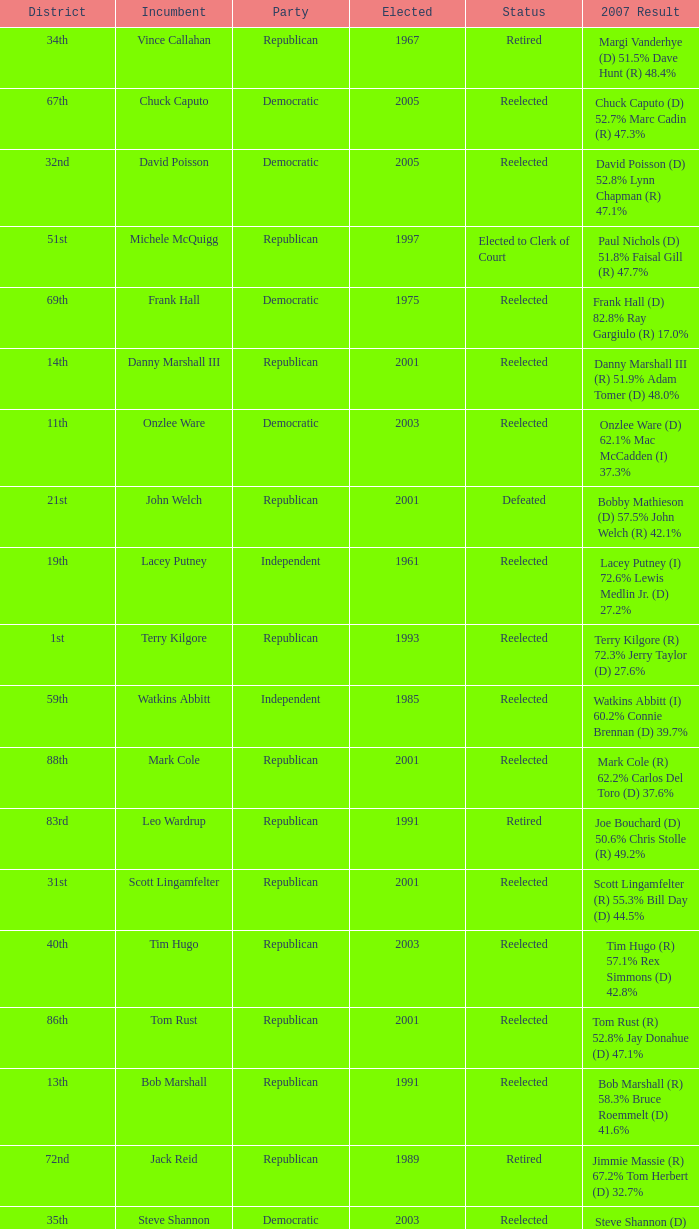How many times was incumbent onzlee ware elected? 1.0. Write the full table. {'header': ['District', 'Incumbent', 'Party', 'Elected', 'Status', '2007 Result'], 'rows': [['34th', 'Vince Callahan', 'Republican', '1967', 'Retired', 'Margi Vanderhye (D) 51.5% Dave Hunt (R) 48.4%'], ['67th', 'Chuck Caputo', 'Democratic', '2005', 'Reelected', 'Chuck Caputo (D) 52.7% Marc Cadin (R) 47.3%'], ['32nd', 'David Poisson', 'Democratic', '2005', 'Reelected', 'David Poisson (D) 52.8% Lynn Chapman (R) 47.1%'], ['51st', 'Michele McQuigg', 'Republican', '1997', 'Elected to Clerk of Court', 'Paul Nichols (D) 51.8% Faisal Gill (R) 47.7%'], ['69th', 'Frank Hall', 'Democratic', '1975', 'Reelected', 'Frank Hall (D) 82.8% Ray Gargiulo (R) 17.0%'], ['14th', 'Danny Marshall III', 'Republican', '2001', 'Reelected', 'Danny Marshall III (R) 51.9% Adam Tomer (D) 48.0%'], ['11th', 'Onzlee Ware', 'Democratic', '2003', 'Reelected', 'Onzlee Ware (D) 62.1% Mac McCadden (I) 37.3%'], ['21st', 'John Welch', 'Republican', '2001', 'Defeated', 'Bobby Mathieson (D) 57.5% John Welch (R) 42.1%'], ['19th', 'Lacey Putney', 'Independent', '1961', 'Reelected', 'Lacey Putney (I) 72.6% Lewis Medlin Jr. (D) 27.2%'], ['1st', 'Terry Kilgore', 'Republican', '1993', 'Reelected', 'Terry Kilgore (R) 72.3% Jerry Taylor (D) 27.6%'], ['59th', 'Watkins Abbitt', 'Independent', '1985', 'Reelected', 'Watkins Abbitt (I) 60.2% Connie Brennan (D) 39.7%'], ['88th', 'Mark Cole', 'Republican', '2001', 'Reelected', 'Mark Cole (R) 62.2% Carlos Del Toro (D) 37.6%'], ['83rd', 'Leo Wardrup', 'Republican', '1991', 'Retired', 'Joe Bouchard (D) 50.6% Chris Stolle (R) 49.2%'], ['31st', 'Scott Lingamfelter', 'Republican', '2001', 'Reelected', 'Scott Lingamfelter (R) 55.3% Bill Day (D) 44.5%'], ['40th', 'Tim Hugo', 'Republican', '2003', 'Reelected', 'Tim Hugo (R) 57.1% Rex Simmons (D) 42.8%'], ['86th', 'Tom Rust', 'Republican', '2001', 'Reelected', 'Tom Rust (R) 52.8% Jay Donahue (D) 47.1%'], ['13th', 'Bob Marshall', 'Republican', '1991', 'Reelected', 'Bob Marshall (R) 58.3% Bruce Roemmelt (D) 41.6%'], ['72nd', 'Jack Reid', 'Republican', '1989', 'Retired', 'Jimmie Massie (R) 67.2% Tom Herbert (D) 32.7%'], ['35th', 'Steve Shannon', 'Democratic', '2003', 'Reelected', 'Steve Shannon (D) 63.4% Arthur Purves (R) 36.6%'], ['54th', 'Bobby Orrock', 'Republican', '1989', 'Reelected', 'Bobby Orrock (R) 73.7% Kimbra Kincheloe (I) 26.2%'], ['39th', 'Vivian Watts', 'Democratic', '1995', 'Reelected', 'Vivian Watts (D) 78.3% Laura C. Clifton (IG) 21.2%'], ['7th', 'Dave Nutter', 'Republican', '2001', 'Reelected', 'Dave Nutter (R) 52.7% Peggy Frank (D) 47.3%'], ['45th', 'David Englin', 'Democratic', '2005', 'Reelected', 'David Englin (D) 64.2% Mark Allen (R) 35.7%'], ['26th', 'Matt Lohr', 'Republican', '2005', 'Reelected', 'Matt Lohr (R) 71.1% Carolyn Frank (I) 28.5%'], ['33rd', 'Joe May', 'Republican', '1993', 'Reelected', 'Joe May (R) 59.8% Marty Martinez (D) 40.0%'], ['16th', 'Robert Hurt', 'Republican', '2001', 'Elected to State Senate', 'Donald Merricks (R) 64.0% Andy Parker (D) 35.9%'], ['78th', 'John Cosgrove', 'Republican', '2001', 'Reelected', 'John Cosgrove (R) 61.7% Mick Meyer (D) 38.2%'], ['82nd', 'Bob Purkey', 'Republican', '1985', 'Reelected', 'Bob Purkey (R) 60.6% Bob MacIver (D) 39.2%'], ['87th', 'Paula Miller', 'Democratic', '2005', 'Reelected', 'Paula Miller (D) 54.0% Hank Giffin (R) 45.8%'], ['56th', 'Bill Janis', 'Republican', '2001', 'Reelected', 'Bill Janis (R) 65.9% Will Shaw (D) 34.0%']]} 